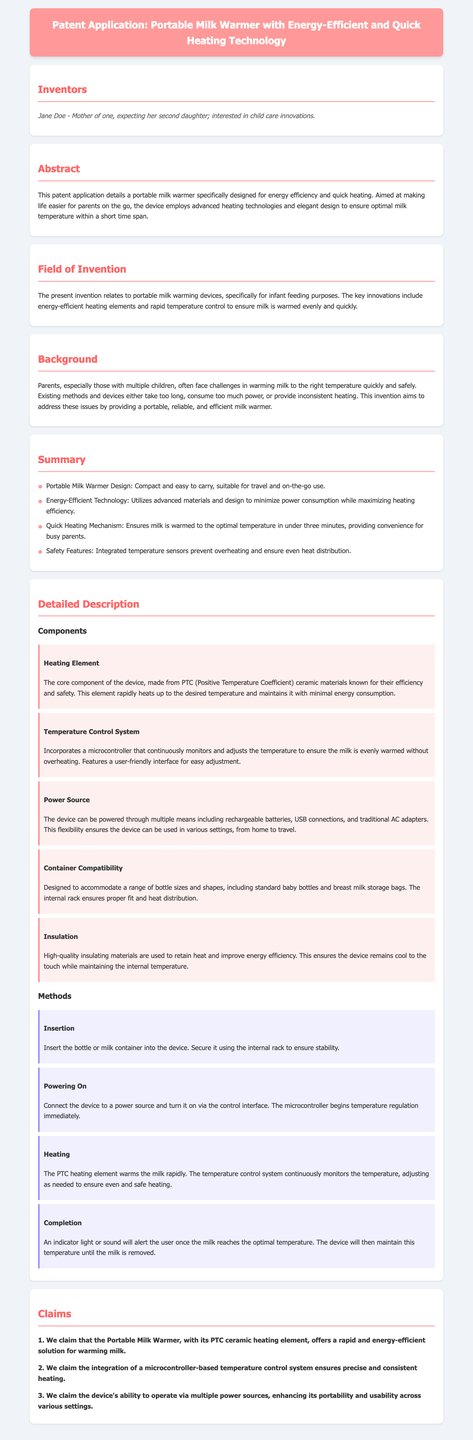What is the invention related to? The invention is related to portable milk warming devices specifically for infant feeding purposes.
Answer: portable milk warming devices Who is the inventor? The document mentions the inventor's name and some background.
Answer: Jane Doe What materials are used in the heating element? The heating element is described as being made from specific efficient materials.
Answer: PTC ceramic materials How quickly can the device warm milk? The quick heating mechanism is highlighted in the summary, providing a specific time frame.
Answer: under three minutes What type of control system is integrated? The detailed description outlines the control system used in the invention.
Answer: microcontroller How does the device notify when heating is complete? The document specifies how the device indicates that the milk has reached the optimal temperature.
Answer: indicator light or sound What do the claims emphasize about the invention? The claims section lists specific features that are essential to the invention's novelty.
Answer: energy-efficient solution What is a safety feature included in the device? The summary mentions safety aspects that are critical for the device's operation.
Answer: integrated temperature sensors What ensures compatibility with various containers? The detailed description covers part of the design that aids in this compatibility.
Answer: internal rack 